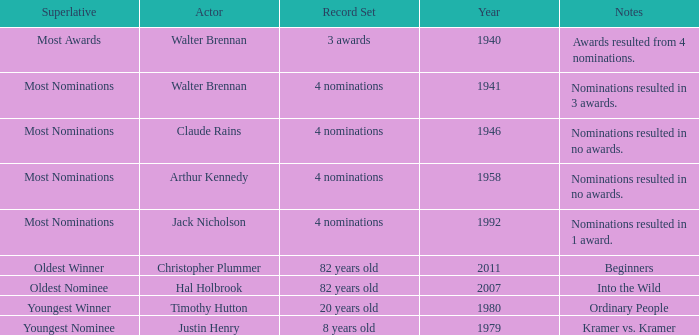What record was set by walter brennan before 1941? 3 awards. 